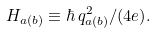Convert formula to latex. <formula><loc_0><loc_0><loc_500><loc_500>H _ { a ( b ) } \equiv \hbar { \, } q _ { a ( b ) } ^ { 2 } / ( 4 e ) .</formula> 